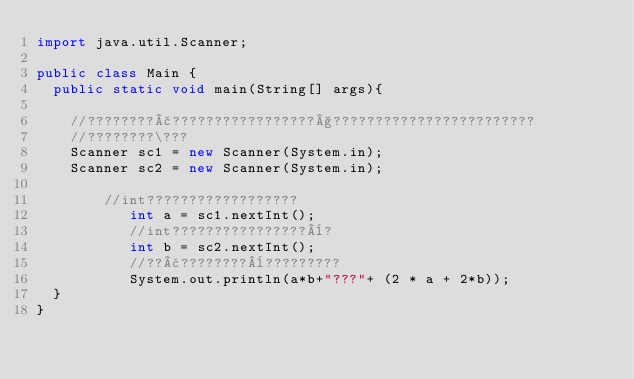<code> <loc_0><loc_0><loc_500><loc_500><_Java_>import java.util.Scanner;

public class Main {
	public static void main(String[] args){

		//????????£?????????????????§????????????????????????
		//????????\???
		Scanner sc1 = new Scanner(System.in);
		Scanner sc2 = new Scanner(System.in);

				//int??????????????????
			     int a = sc1.nextInt();
			     //int????????????????¨?
			     int b = sc2.nextInt();
			     //??¢????????¨?????????
			     System.out.println(a*b+"???"+ (2 * a + 2*b));
	}
}</code> 